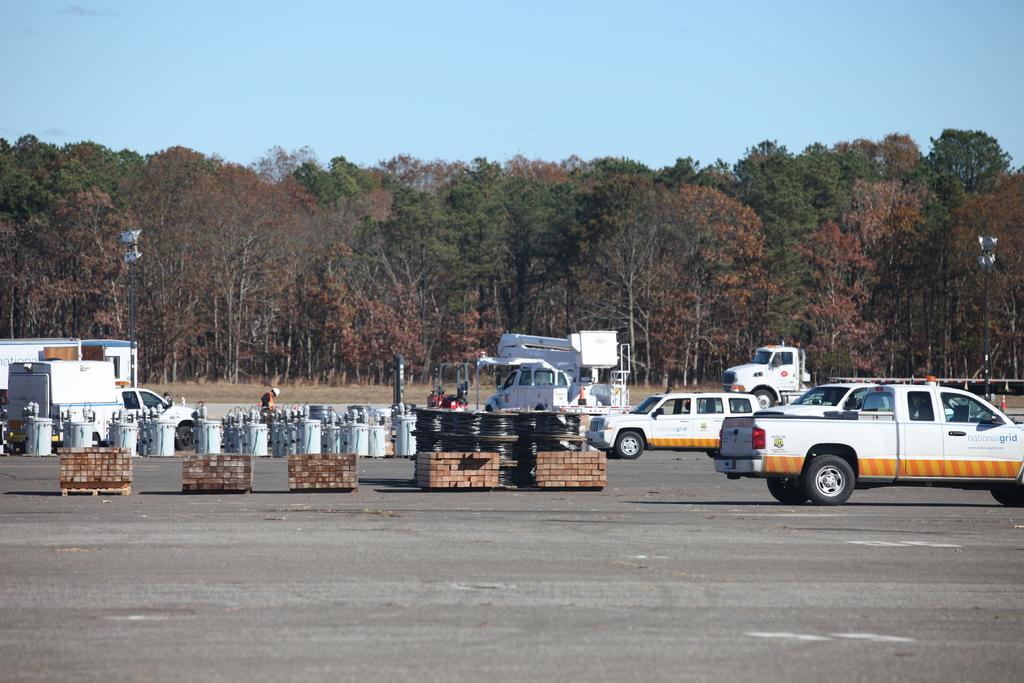How would you summarize this image in a sentence or two? In this picture I can observe some vehicles moving on the road. These vehicles are in white color. In the background I can observe trees and sky. 